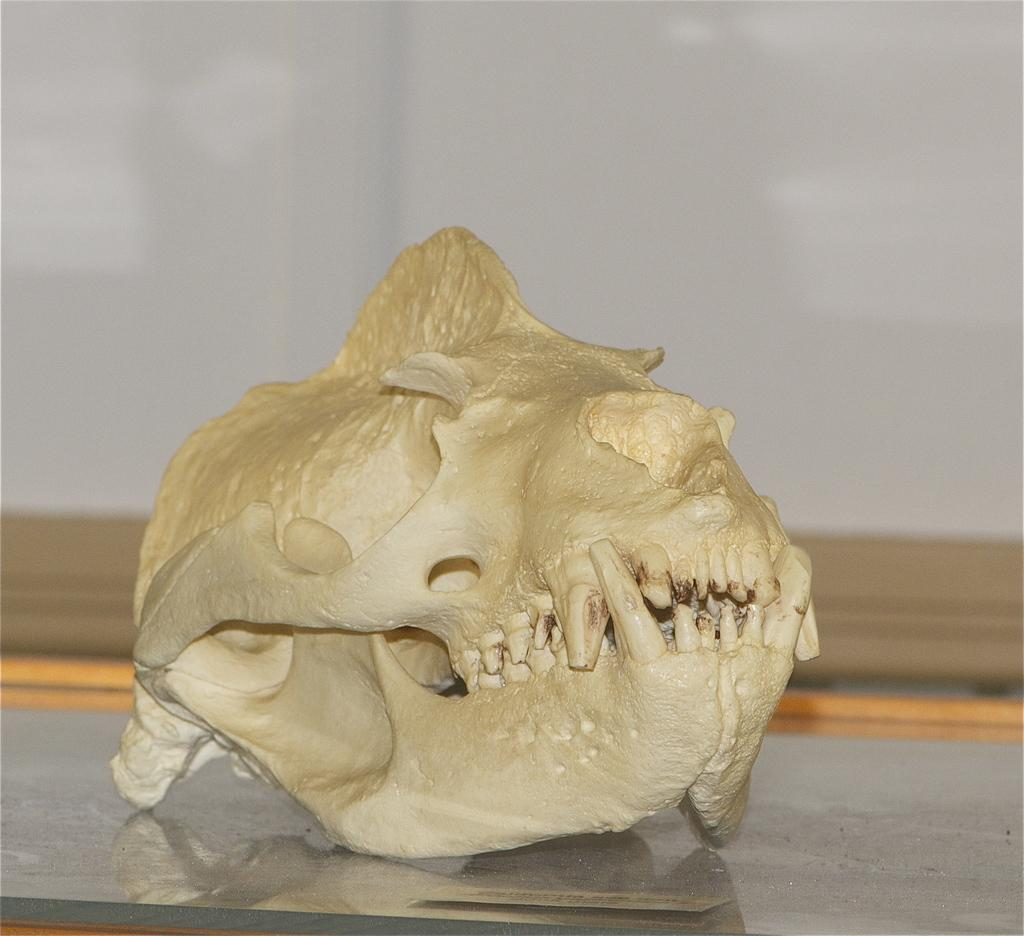What is the main subject of the image? The main subject of the image is a skull. How is the skull positioned in the image? The skull is on a glass platform. What can be seen in the background of the image? There is a wall in the background of the image. What type of sack can be seen hanging from the skull in the image? There is no sack present in the image, and the skull is not holding or supporting any object. 